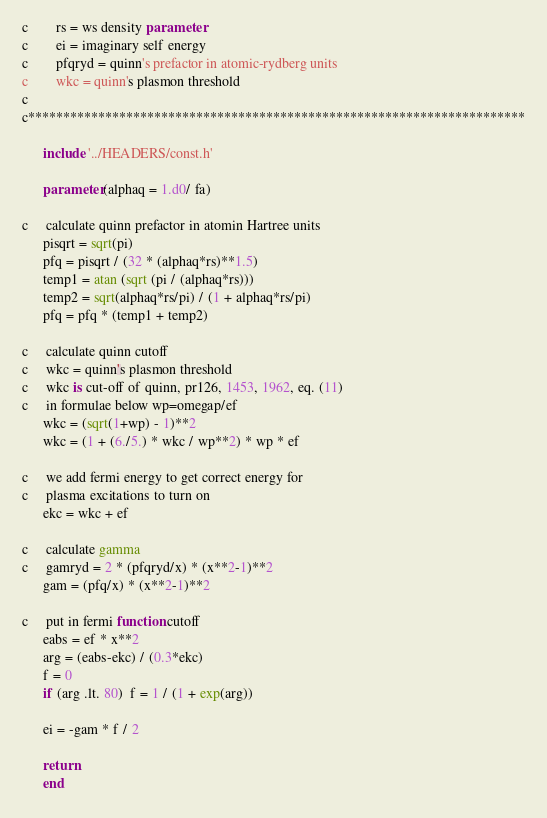Convert code to text. <code><loc_0><loc_0><loc_500><loc_500><_FORTRAN_>c        rs = ws density parameter
c        ei = imaginary self energy
c        pfqryd = quinn's prefactor in atomic-rydberg units
c        wkc = quinn's plasmon threshold
c
c***********************************************************************

      include '../HEADERS/const.h'

      parameter (alphaq = 1.d0/ fa)

c     calculate quinn prefactor in atomin Hartree units
      pisqrt = sqrt(pi)
      pfq = pisqrt / (32 * (alphaq*rs)**1.5)
      temp1 = atan (sqrt (pi / (alphaq*rs)))
      temp2 = sqrt(alphaq*rs/pi) / (1 + alphaq*rs/pi)
      pfq = pfq * (temp1 + temp2)

c     calculate quinn cutoff
c     wkc = quinn's plasmon threshold
c     wkc is cut-off of quinn, pr126, 1453, 1962, eq. (11)
c     in formulae below wp=omegap/ef
      wkc = (sqrt(1+wp) - 1)**2
      wkc = (1 + (6./5.) * wkc / wp**2) * wp * ef

c     we add fermi energy to get correct energy for
c     plasma excitations to turn on
      ekc = wkc + ef

c     calculate gamma
c     gamryd = 2 * (pfqryd/x) * (x**2-1)**2
      gam = (pfq/x) * (x**2-1)**2

c     put in fermi function cutoff
      eabs = ef * x**2
      arg = (eabs-ekc) / (0.3*ekc)
      f = 0
      if (arg .lt. 80)  f = 1 / (1 + exp(arg))

      ei = -gam * f / 2

      return
      end
</code> 